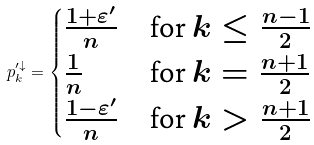<formula> <loc_0><loc_0><loc_500><loc_500>p _ { k } ^ { \prime \downarrow } = \begin{cases} \frac { 1 + \varepsilon ^ { \prime } } { n } & \text {for } k \leq \frac { n - 1 } { 2 } \\ \frac { 1 } { n } & \text {for } k = \frac { n + 1 } { 2 } \\ \frac { 1 - \varepsilon ^ { \prime } } { n } & \text {for } k > \frac { n + 1 } { 2 } \end{cases}</formula> 